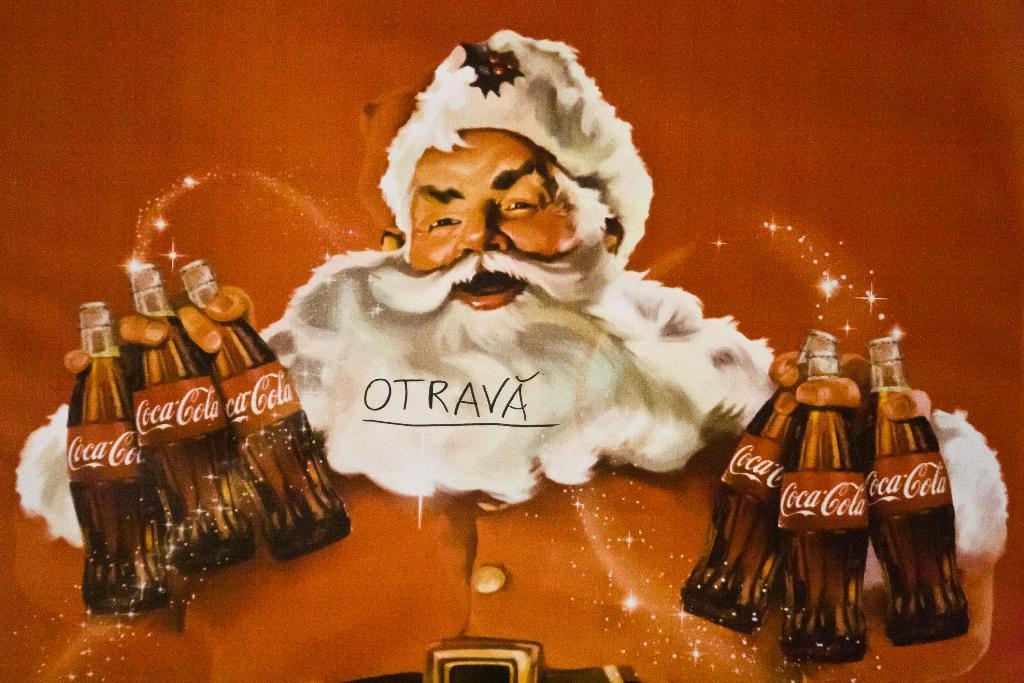Could you give a brief overview of what you see in this image? This is an animation in this image in the center, there is one person who is holding bottles in his hand. 